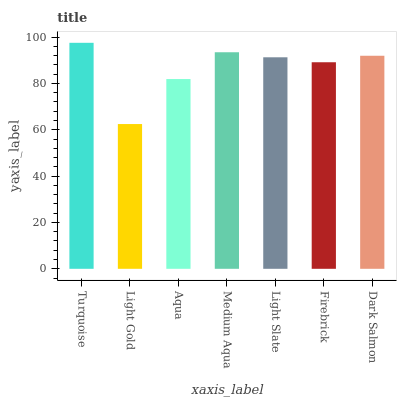Is Light Gold the minimum?
Answer yes or no. Yes. Is Turquoise the maximum?
Answer yes or no. Yes. Is Aqua the minimum?
Answer yes or no. No. Is Aqua the maximum?
Answer yes or no. No. Is Aqua greater than Light Gold?
Answer yes or no. Yes. Is Light Gold less than Aqua?
Answer yes or no. Yes. Is Light Gold greater than Aqua?
Answer yes or no. No. Is Aqua less than Light Gold?
Answer yes or no. No. Is Light Slate the high median?
Answer yes or no. Yes. Is Light Slate the low median?
Answer yes or no. Yes. Is Firebrick the high median?
Answer yes or no. No. Is Firebrick the low median?
Answer yes or no. No. 